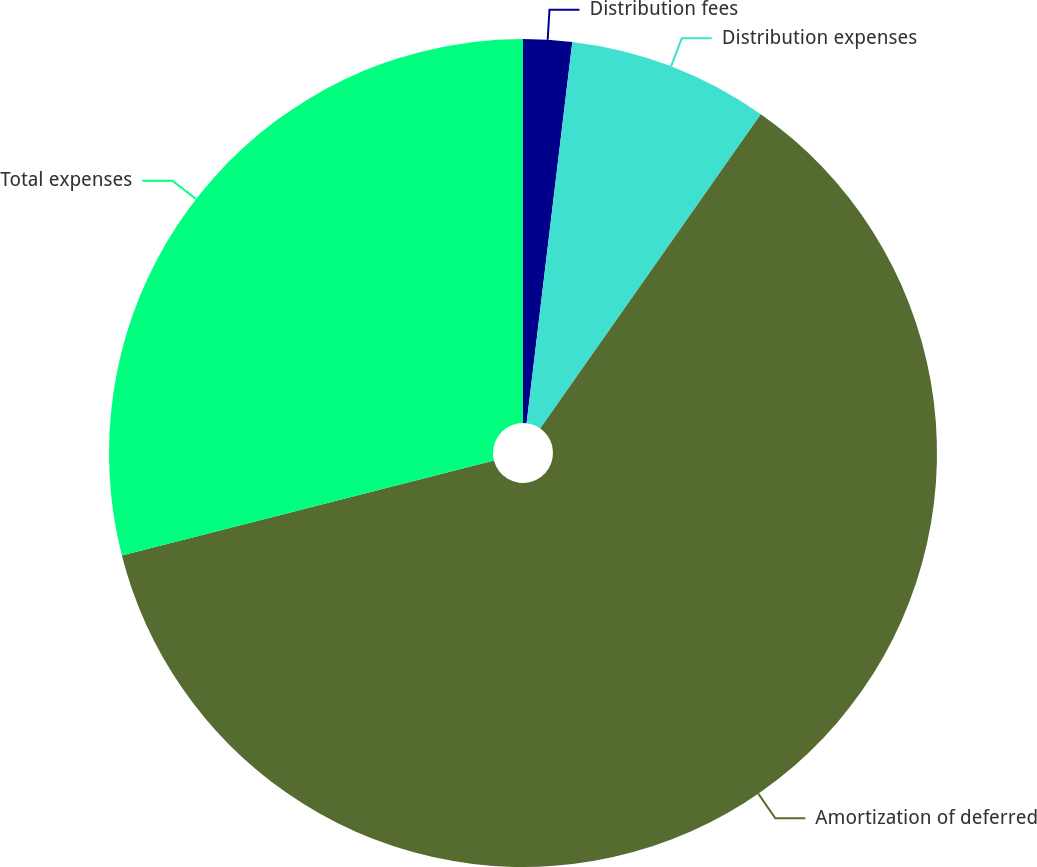Convert chart. <chart><loc_0><loc_0><loc_500><loc_500><pie_chart><fcel>Distribution fees<fcel>Distribution expenses<fcel>Amortization of deferred<fcel>Total expenses<nl><fcel>1.9%<fcel>7.84%<fcel>61.28%<fcel>28.98%<nl></chart> 